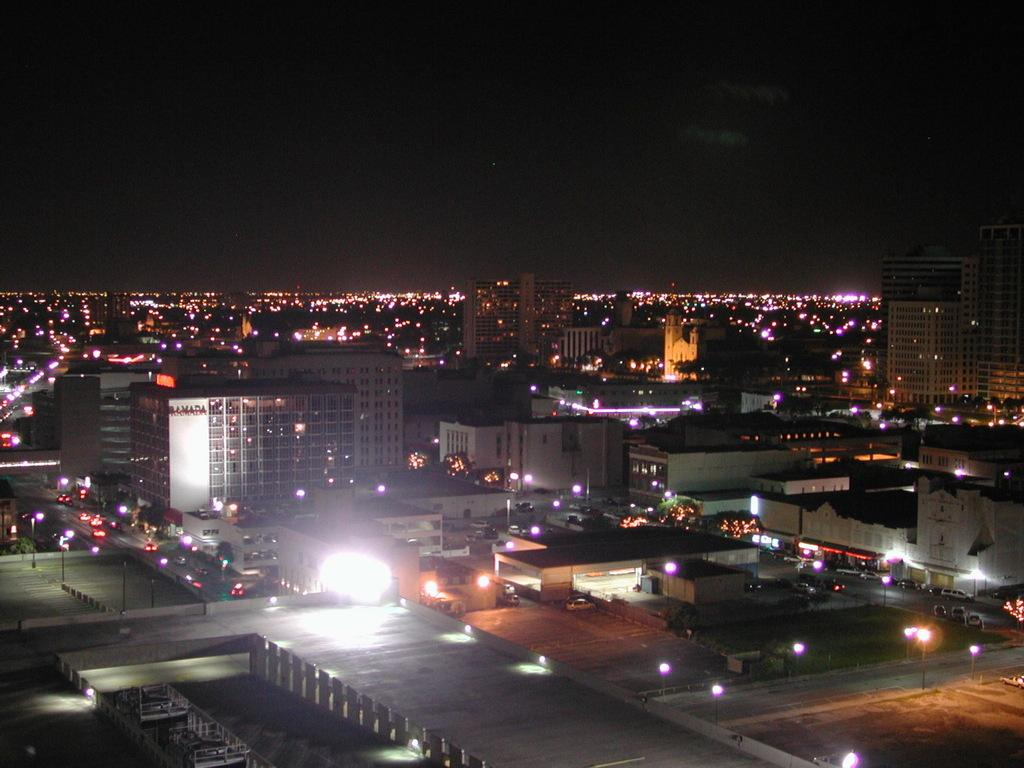What type of structures can be seen in the image? There are buildings in the image. What else is visible in the image besides the buildings? There are lights and vehicles on the road visible in the image. Are there any other objects present in the image? Yes, there are poles in the image. What type of bell can be heard ringing in the image? There is no bell present in the image, and therefore no sound can be heard. 